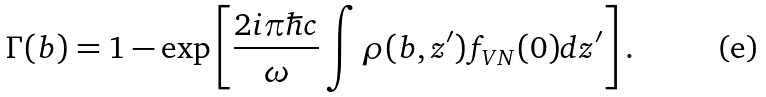<formula> <loc_0><loc_0><loc_500><loc_500>\Gamma ( b ) = 1 - \exp \left [ \frac { 2 i \pi \hbar { c } } { \omega } \int \rho ( b , z ^ { \prime } ) f _ { V N } ( 0 ) d z ^ { \prime } \right ] .</formula> 